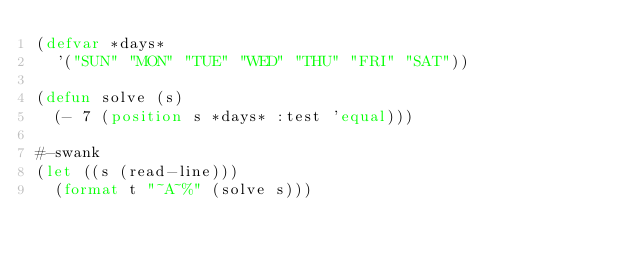Convert code to text. <code><loc_0><loc_0><loc_500><loc_500><_Lisp_>(defvar *days*
  '("SUN" "MON" "TUE" "WED" "THU" "FRI" "SAT"))

(defun solve (s)
  (- 7 (position s *days* :test 'equal)))

#-swank
(let ((s (read-line)))
  (format t "~A~%" (solve s)))
</code> 